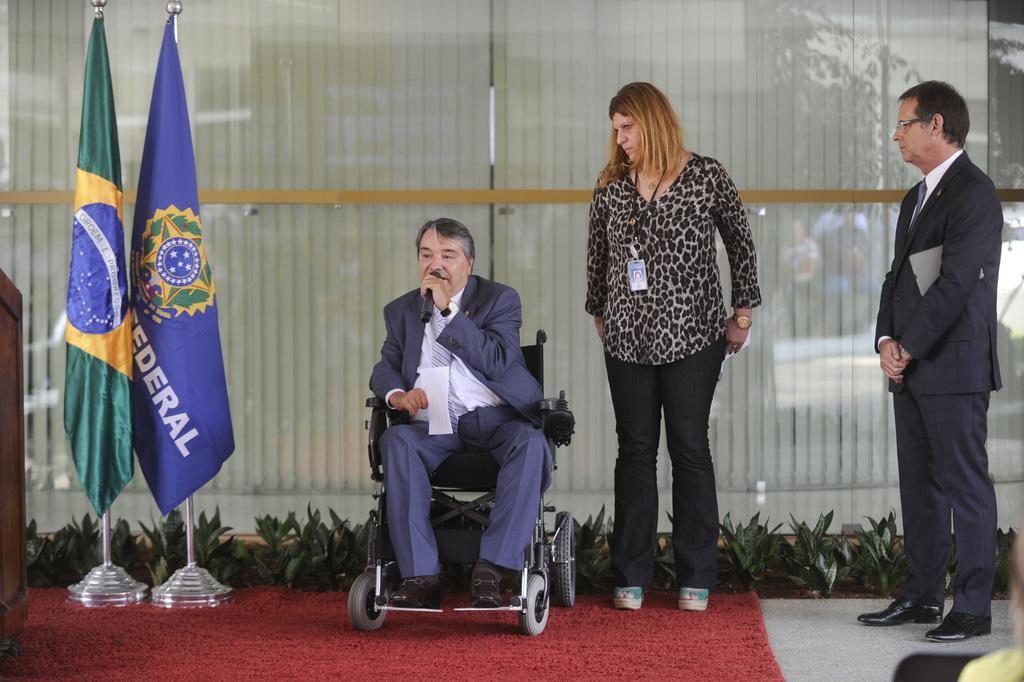Could you give a brief overview of what you see in this image? In this image, we can see a few people. Among them, we can see a person holding a microphone is sitting on a wheel chair. We can see the ground with the carpet. We can see some flags, plants. We can see the glass wall. 